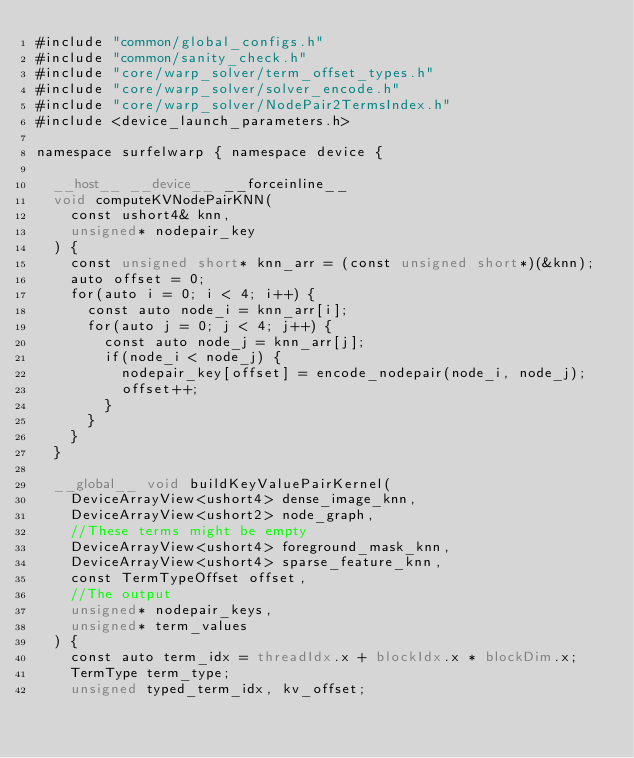Convert code to text. <code><loc_0><loc_0><loc_500><loc_500><_Cuda_>#include "common/global_configs.h"
#include "common/sanity_check.h"
#include "core/warp_solver/term_offset_types.h"
#include "core/warp_solver/solver_encode.h"
#include "core/warp_solver/NodePair2TermsIndex.h"
#include <device_launch_parameters.h>

namespace surfelwarp { namespace device {

	__host__ __device__ __forceinline__ 
	void computeKVNodePairKNN(
		const ushort4& knn,
		unsigned* nodepair_key
	) {
		const unsigned short* knn_arr = (const unsigned short*)(&knn);
		auto offset = 0;
		for(auto i = 0; i < 4; i++) {
			const auto node_i = knn_arr[i];
			for(auto j = 0; j < 4; j++) {
				const auto node_j = knn_arr[j];
				if(node_i < node_j) {
					nodepair_key[offset] = encode_nodepair(node_i, node_j);
					offset++;
				}
			}
		}
	}
	
	__global__ void buildKeyValuePairKernel(
		DeviceArrayView<ushort4> dense_image_knn,
		DeviceArrayView<ushort2> node_graph,
		//These terms might be empty
		DeviceArrayView<ushort4> foreground_mask_knn,
		DeviceArrayView<ushort4> sparse_feature_knn,
		const TermTypeOffset offset,
		//The output
		unsigned* nodepair_keys,
		unsigned* term_values
	) {
		const auto term_idx = threadIdx.x + blockIdx.x * blockDim.x;
		TermType term_type;
		unsigned typed_term_idx, kv_offset;</code> 